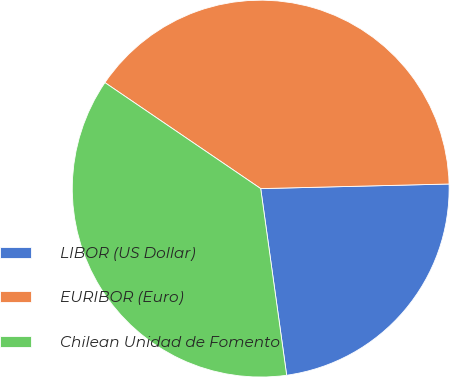Convert chart. <chart><loc_0><loc_0><loc_500><loc_500><pie_chart><fcel>LIBOR (US Dollar)<fcel>EURIBOR (Euro)<fcel>Chilean Unidad de Fomento<nl><fcel>23.19%<fcel>40.1%<fcel>36.71%<nl></chart> 